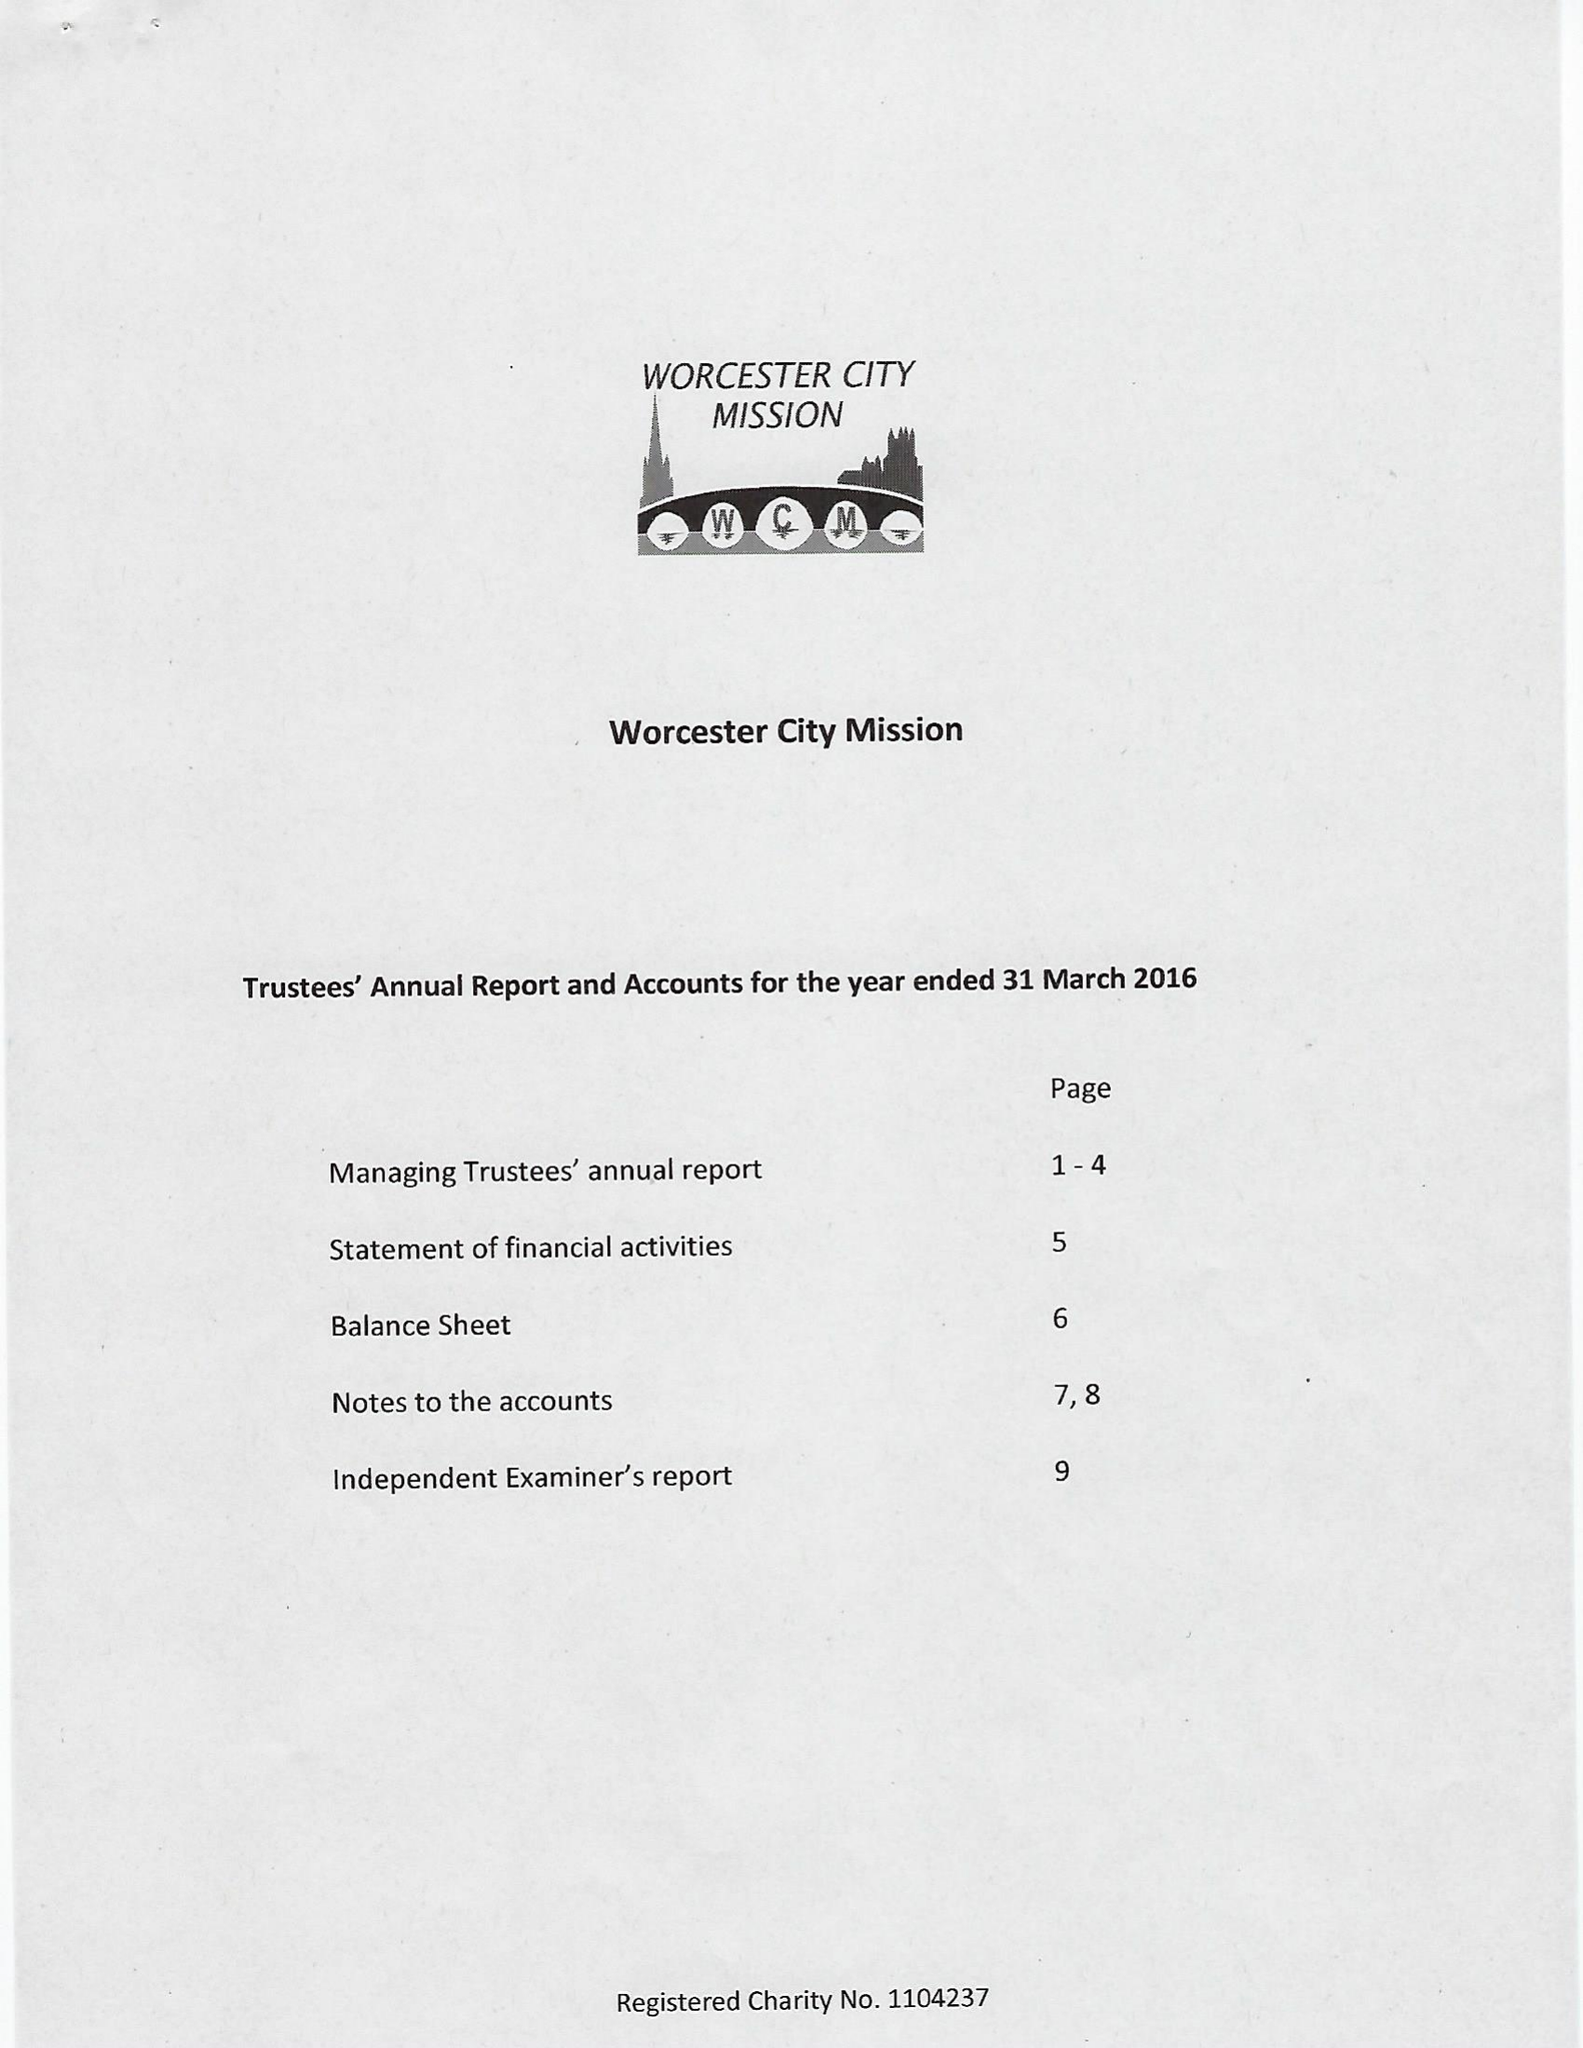What is the value for the charity_name?
Answer the question using a single word or phrase. Worcester City Mission 